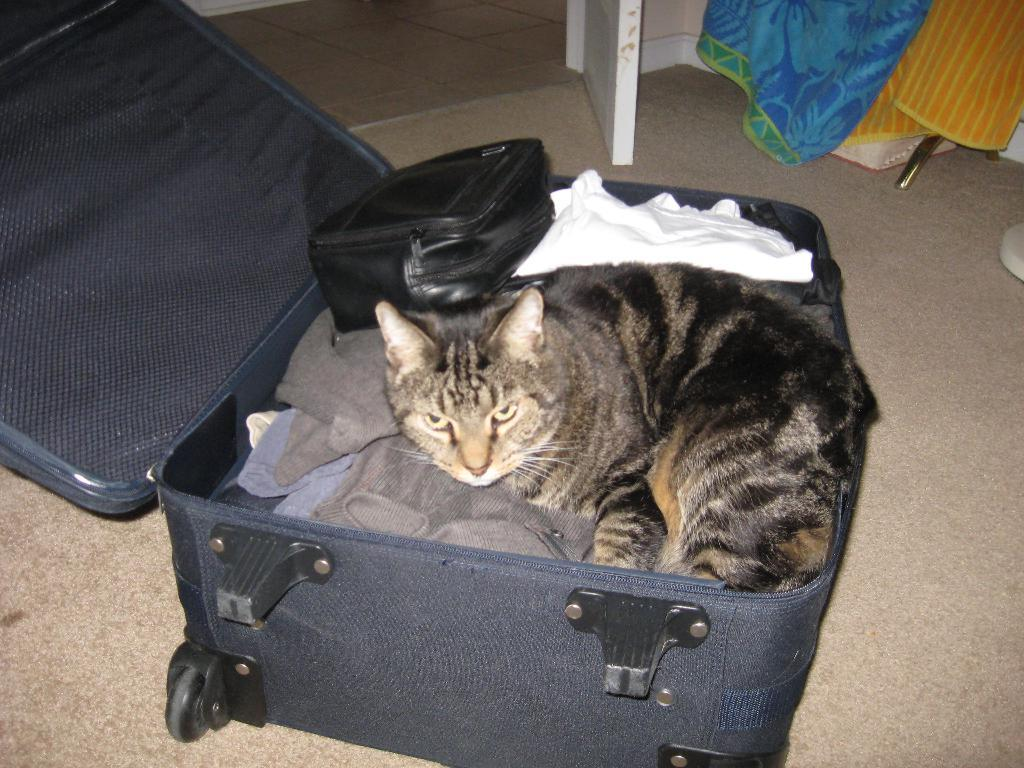What object can be seen in the image that is commonly used for carrying belongings? There is a suitcase in the image that is commonly used for carrying belongings. What items are inside the suitcase? The suitcase contains clothes. Is there any other bag visible inside the suitcase? Yes, there is a black bag in the suitcase. What unexpected item is also present in the suitcase? A cat is inside the suitcase. What can be seen hanging in the background of the image? There is a blue cloth hanging in the background of the image. What type of laborer is shown working with a bucket in the image? There is no laborer or bucket present in the image. How does the cat blow air into the suitcase in the image? The cat does not blow air into the suitcase in the image; it is simply inside the suitcase. 